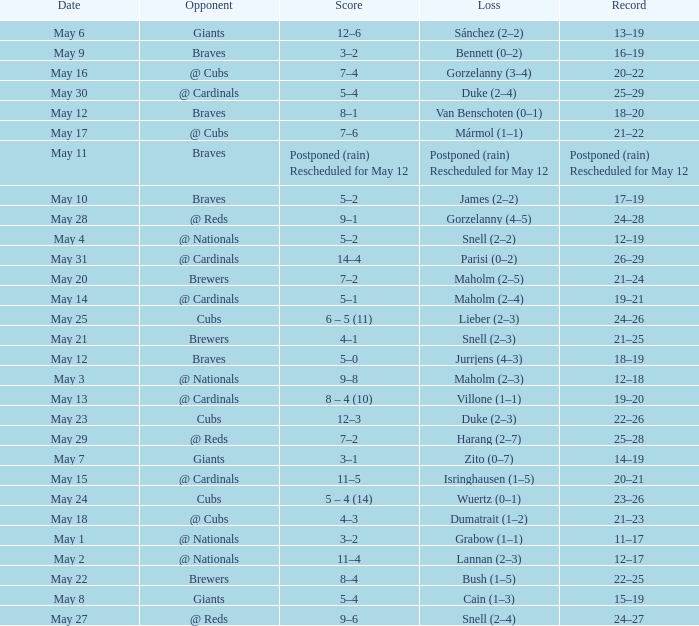What was the score of the game with a loss of Maholm (2–4)? 5–1. 